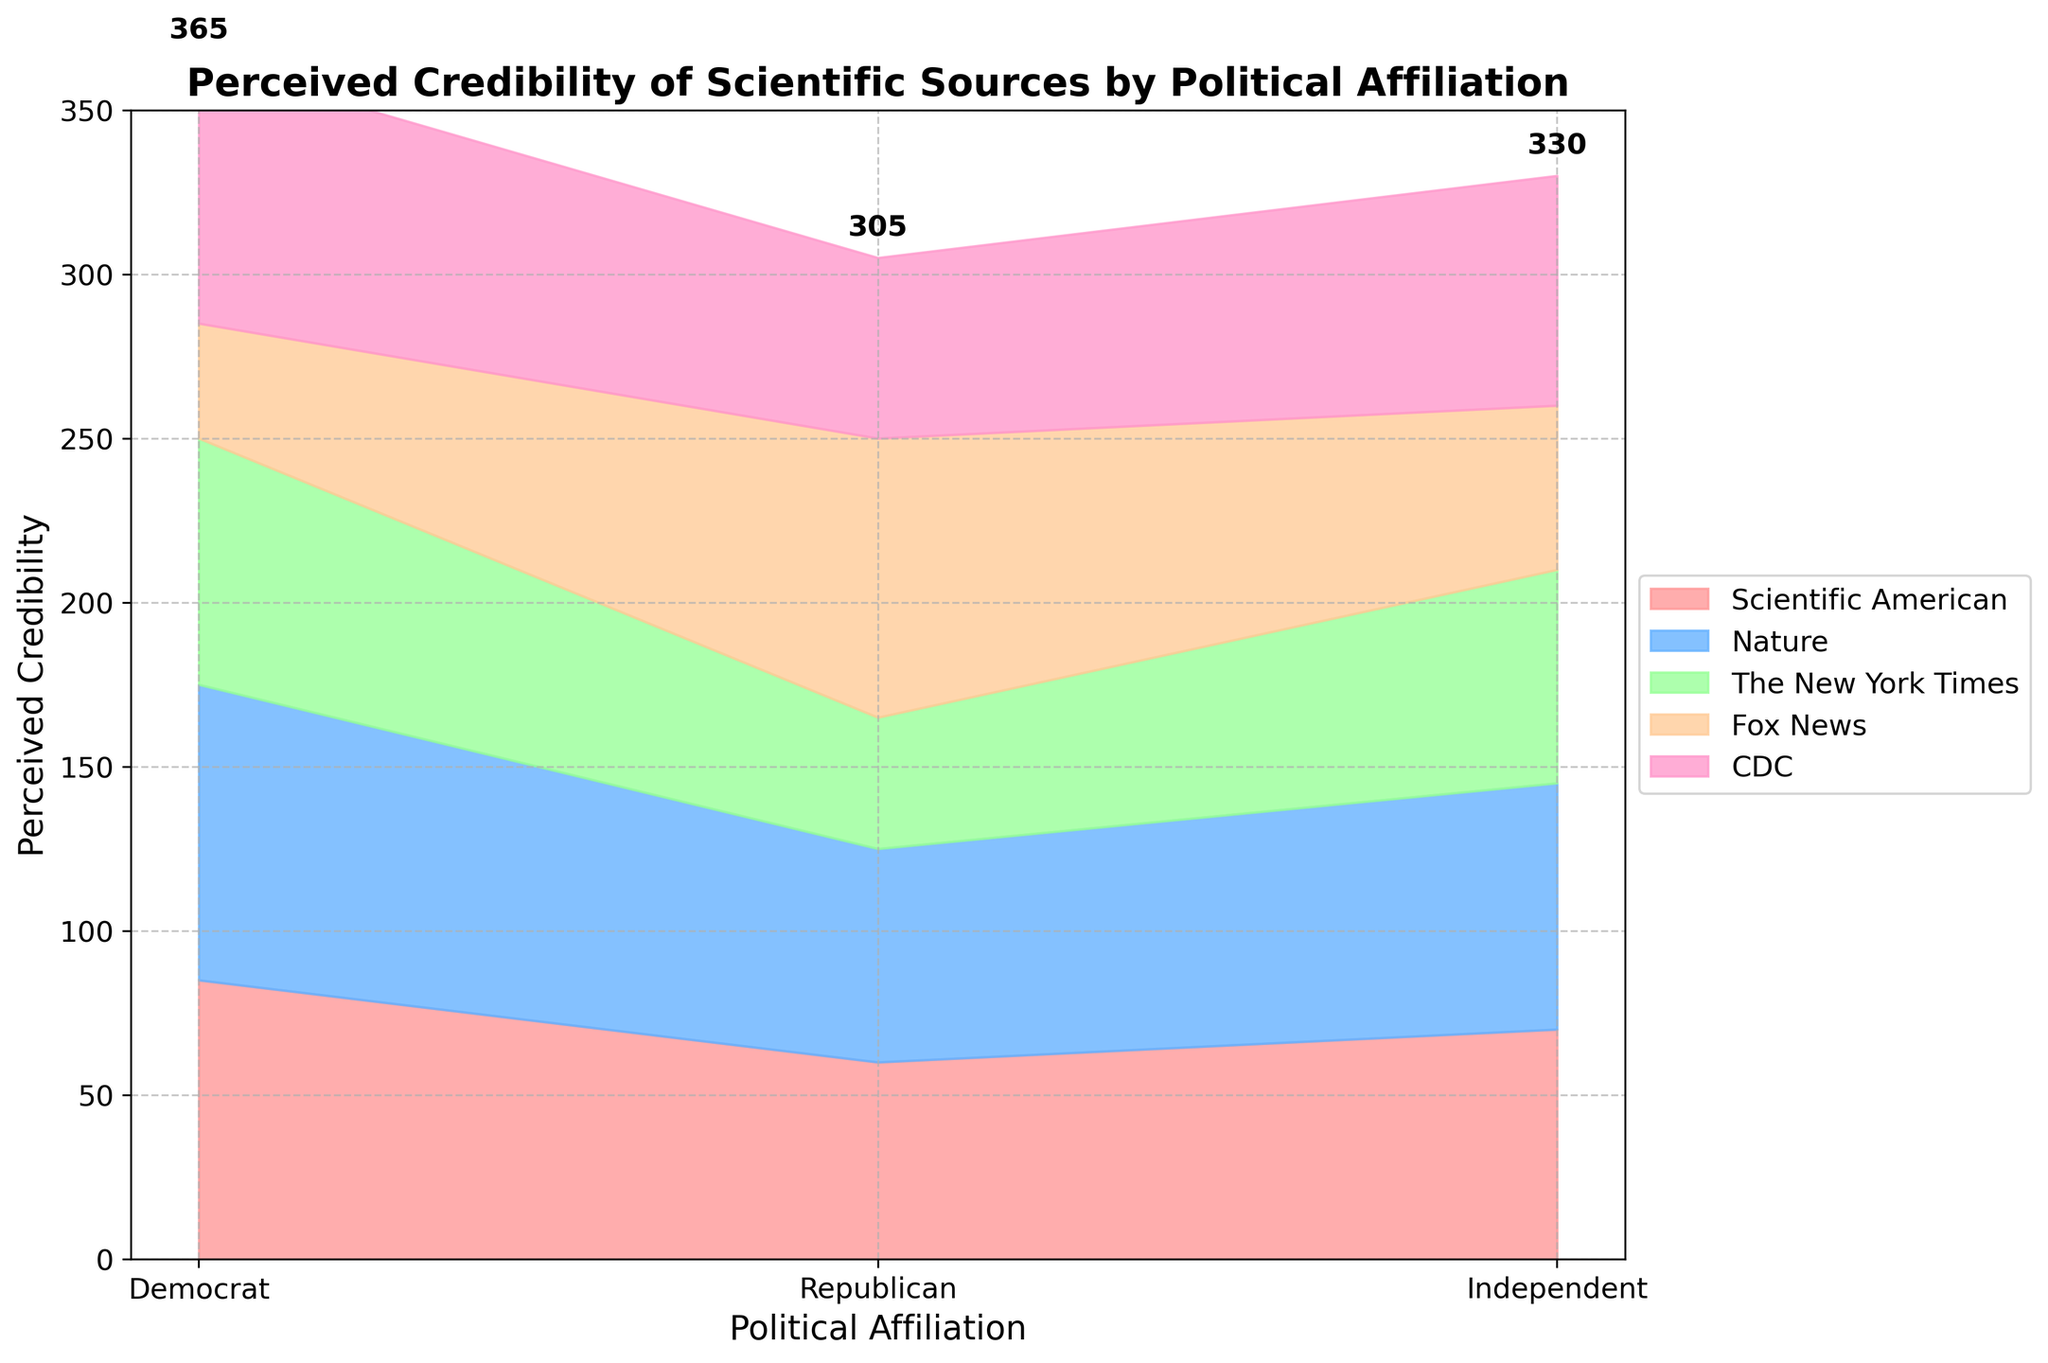What's the title of the chart? The title of the chart is prominently displayed at the top of the figure. It summarizes the main subject of the visualization.
Answer: Perceived Credibility of Scientific Sources by Political Affiliation How many political affiliations are represented in the chart? By observing the x-axis labels, you can count the number of unique political affiliations shown.
Answer: 3 What is the perceived credibility of 'Nature' by Republicans? Locate the section for Republicans on the x-axis and refer to the colored area segment labeled 'Nature' to determine the perceived credibility value.
Answer: 65 Which scientific source has the highest perceived credibility among Democrats? Identify the section for Democrats on the x-axis and compare the height of the colored segments to determine which source reaches the highest value.
Answer: Nature What is the sum of perceived credibility for 'The New York Times' across all political affiliations? Add the perceived credibility values of 'The New York Times' for each political affiliation: 75 (Democrat) + 40 (Republican) + 65 (Independent).
Answer: 180 How do Republicans rate the credibility of 'CDC' compared to 'Fox News'? Compare the heights of the colored segments for 'CDC' and 'Fox News' within the Republican section of the x-axis.
Answer: Lower Which political affiliation perceives 'Scientific American' as more credible, Independents or Republicans? Compare the heights of the 'Scientific American' segments within the Independent and Republican sections.
Answer: Independents What is the total perceived credibility for all sources among Independents? Sum the perceived credibility values for all sources within the Independent section: 70 + 75 + 65 + 50 + 70.
Answer: 330 Which scientific source shows the largest variation in perceived credibility across political affiliations? Compare the range of perceived credibility values for each source across the three political affiliations, identifying the one with the largest difference between its highest and lowest values.
Answer: Scientific American How does the total perceived credibility of 'Fox News' compare between Democrats and Republicans? Compare the total perceived credibility values for 'Fox News' by examining the heights within the Democrat and Republican sections on the x-axis.
Answer: Higher for Republicans 